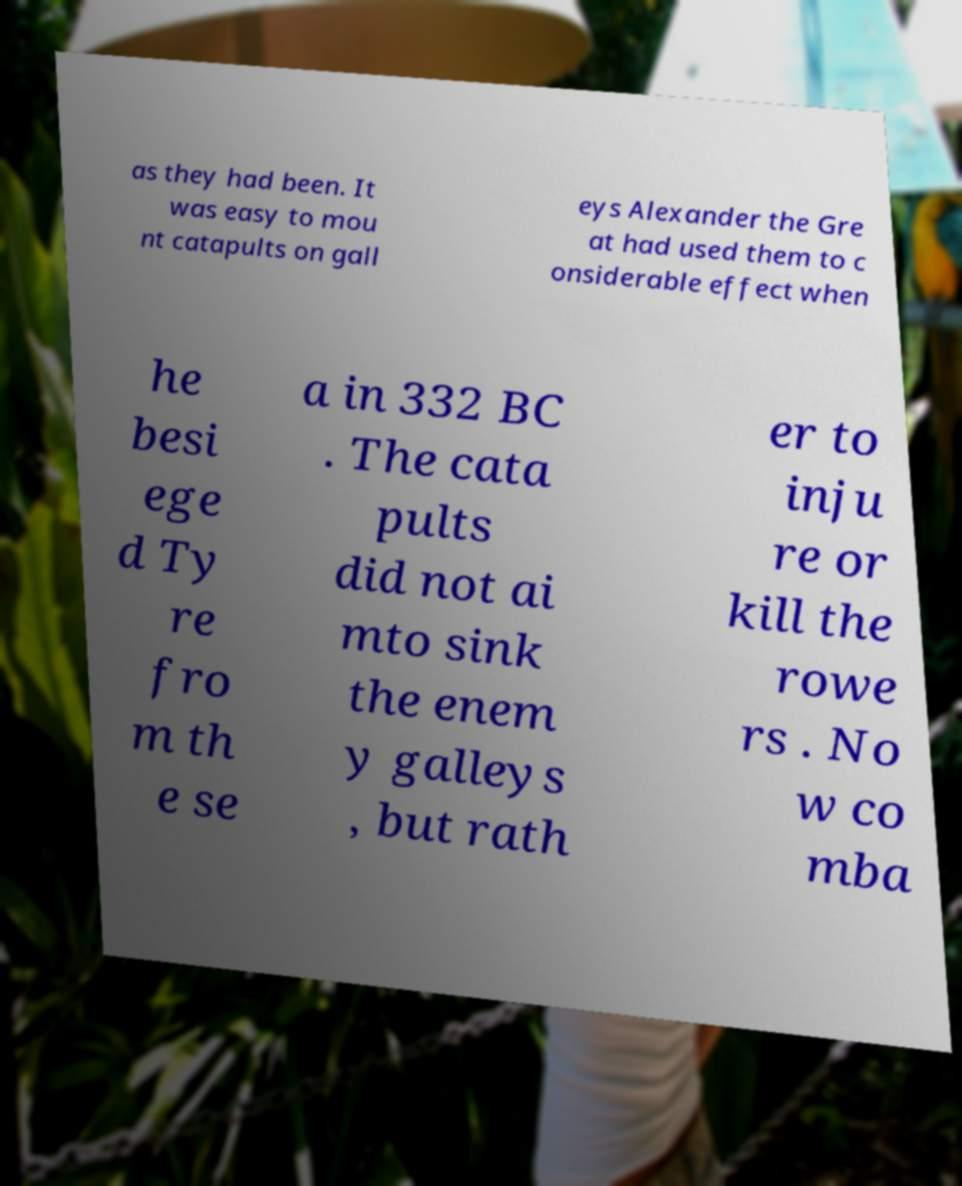Could you assist in decoding the text presented in this image and type it out clearly? as they had been. It was easy to mou nt catapults on gall eys Alexander the Gre at had used them to c onsiderable effect when he besi ege d Ty re fro m th e se a in 332 BC . The cata pults did not ai mto sink the enem y galleys , but rath er to inju re or kill the rowe rs . No w co mba 